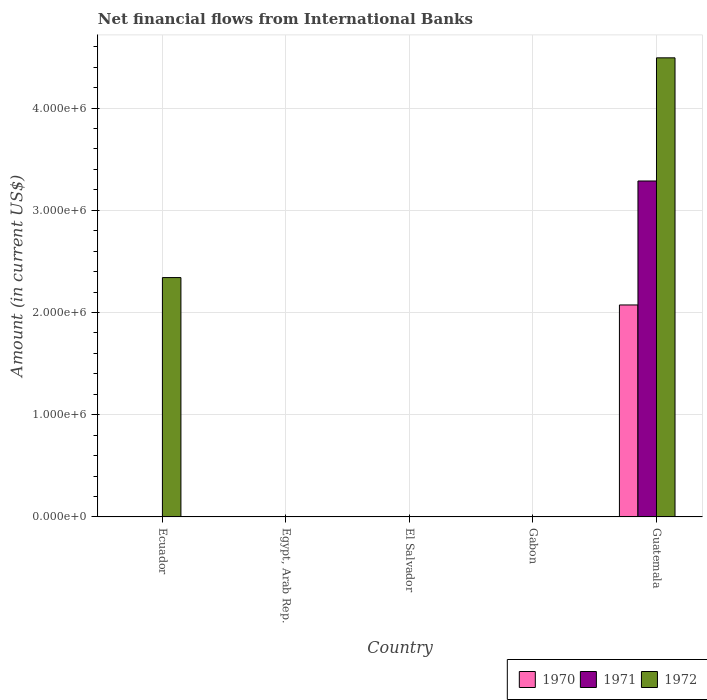Are the number of bars per tick equal to the number of legend labels?
Provide a short and direct response. No. Are the number of bars on each tick of the X-axis equal?
Your answer should be very brief. No. How many bars are there on the 5th tick from the right?
Give a very brief answer. 1. What is the label of the 5th group of bars from the left?
Your answer should be very brief. Guatemala. In how many cases, is the number of bars for a given country not equal to the number of legend labels?
Offer a very short reply. 4. What is the net financial aid flows in 1972 in El Salvador?
Keep it short and to the point. 0. Across all countries, what is the maximum net financial aid flows in 1970?
Your response must be concise. 2.07e+06. In which country was the net financial aid flows in 1972 maximum?
Give a very brief answer. Guatemala. What is the total net financial aid flows in 1970 in the graph?
Give a very brief answer. 2.07e+06. What is the difference between the net financial aid flows in 1972 in Ecuador and the net financial aid flows in 1970 in Gabon?
Your answer should be compact. 2.34e+06. What is the average net financial aid flows in 1972 per country?
Give a very brief answer. 1.37e+06. What is the difference between the net financial aid flows of/in 1971 and net financial aid flows of/in 1970 in Guatemala?
Offer a very short reply. 1.21e+06. What is the difference between the highest and the lowest net financial aid flows in 1971?
Provide a succinct answer. 3.29e+06. In how many countries, is the net financial aid flows in 1972 greater than the average net financial aid flows in 1972 taken over all countries?
Offer a very short reply. 2. What is the difference between two consecutive major ticks on the Y-axis?
Give a very brief answer. 1.00e+06. Are the values on the major ticks of Y-axis written in scientific E-notation?
Your response must be concise. Yes. Does the graph contain any zero values?
Offer a very short reply. Yes. How many legend labels are there?
Make the answer very short. 3. What is the title of the graph?
Give a very brief answer. Net financial flows from International Banks. Does "1998" appear as one of the legend labels in the graph?
Keep it short and to the point. No. What is the label or title of the X-axis?
Offer a very short reply. Country. What is the label or title of the Y-axis?
Your answer should be compact. Amount (in current US$). What is the Amount (in current US$) of 1970 in Ecuador?
Give a very brief answer. 0. What is the Amount (in current US$) in 1972 in Ecuador?
Your answer should be very brief. 2.34e+06. What is the Amount (in current US$) in 1970 in Egypt, Arab Rep.?
Your answer should be very brief. 0. What is the Amount (in current US$) of 1971 in Egypt, Arab Rep.?
Keep it short and to the point. 0. What is the Amount (in current US$) of 1970 in El Salvador?
Make the answer very short. 0. What is the Amount (in current US$) of 1972 in El Salvador?
Make the answer very short. 0. What is the Amount (in current US$) of 1970 in Gabon?
Your answer should be very brief. 0. What is the Amount (in current US$) of 1970 in Guatemala?
Make the answer very short. 2.07e+06. What is the Amount (in current US$) of 1971 in Guatemala?
Offer a very short reply. 3.29e+06. What is the Amount (in current US$) in 1972 in Guatemala?
Offer a terse response. 4.49e+06. Across all countries, what is the maximum Amount (in current US$) in 1970?
Make the answer very short. 2.07e+06. Across all countries, what is the maximum Amount (in current US$) of 1971?
Offer a terse response. 3.29e+06. Across all countries, what is the maximum Amount (in current US$) in 1972?
Make the answer very short. 4.49e+06. Across all countries, what is the minimum Amount (in current US$) of 1970?
Provide a succinct answer. 0. Across all countries, what is the minimum Amount (in current US$) of 1972?
Provide a succinct answer. 0. What is the total Amount (in current US$) in 1970 in the graph?
Your response must be concise. 2.07e+06. What is the total Amount (in current US$) of 1971 in the graph?
Provide a short and direct response. 3.29e+06. What is the total Amount (in current US$) of 1972 in the graph?
Ensure brevity in your answer.  6.83e+06. What is the difference between the Amount (in current US$) of 1972 in Ecuador and that in Guatemala?
Your response must be concise. -2.15e+06. What is the average Amount (in current US$) of 1970 per country?
Your answer should be very brief. 4.15e+05. What is the average Amount (in current US$) in 1971 per country?
Offer a terse response. 6.57e+05. What is the average Amount (in current US$) of 1972 per country?
Provide a succinct answer. 1.37e+06. What is the difference between the Amount (in current US$) in 1970 and Amount (in current US$) in 1971 in Guatemala?
Provide a succinct answer. -1.21e+06. What is the difference between the Amount (in current US$) in 1970 and Amount (in current US$) in 1972 in Guatemala?
Offer a terse response. -2.42e+06. What is the difference between the Amount (in current US$) of 1971 and Amount (in current US$) of 1972 in Guatemala?
Give a very brief answer. -1.20e+06. What is the ratio of the Amount (in current US$) of 1972 in Ecuador to that in Guatemala?
Your response must be concise. 0.52. What is the difference between the highest and the lowest Amount (in current US$) in 1970?
Ensure brevity in your answer.  2.07e+06. What is the difference between the highest and the lowest Amount (in current US$) in 1971?
Your response must be concise. 3.29e+06. What is the difference between the highest and the lowest Amount (in current US$) in 1972?
Your response must be concise. 4.49e+06. 